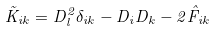<formula> <loc_0><loc_0><loc_500><loc_500>\tilde { K } _ { i k } = D _ { l } ^ { 2 } \delta _ { i k } - D _ { i } D _ { k } - 2 \hat { F } _ { i k }</formula> 